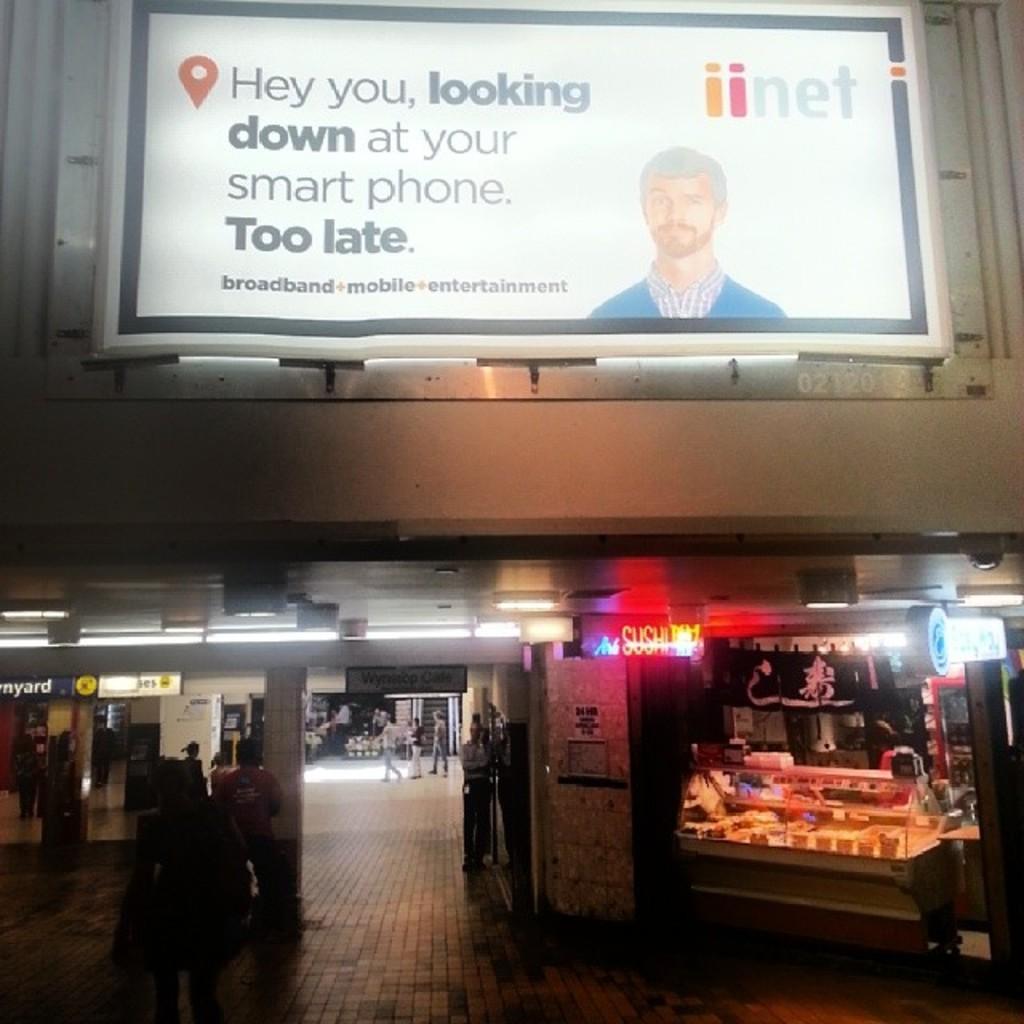In one or two sentences, can you explain what this image depicts? In this picture I can see a building, there are light boards, shops, lights, there are group of people and there are some other objects. 